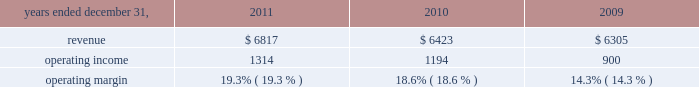2022 net derivative losses of $ 13 million .
Review by segment general we serve clients through the following segments : 2022 risk solutions acts as an advisor and insurance and reinsurance broker , helping clients manage their risks , via consultation , as well as negotiation and placement of insurance risk with insurance carriers through our global distribution network .
2022 hr solutions partners with organizations to solve their most complex benefits , talent and related financial challenges , and improve business performance by designing , implementing , communicating and administering a wide range of human capital , retirement , investment management , health care , compensation and talent management strategies .
Risk solutions .
The demand for property and casualty insurance generally rises as the overall level of economic activity increases and generally falls as such activity decreases , affecting both the commissions and fees generated by our brokerage business .
The economic activity that impacts property and casualty insurance is described as exposure units , and is closely correlated with employment levels , corporate revenue and asset values .
During 2011 we began to see some improvement in pricing ; however , we would still consider this to be a 2018 2018soft market , 2019 2019 which began in 2007 .
In a soft market , premium rates flatten or decrease , along with commission revenues , due to increased competition for market share among insurance carriers or increased underwriting capacity .
Changes in premiums have a direct and potentially material impact on the insurance brokerage industry , as commission revenues are generally based on a percentage of the premiums paid by insureds .
In 2011 , pricing showed signs of stabilization and improvement in both our retail and reinsurance brokerage product lines and we expect this trend to slowly continue into 2012 .
Additionally , beginning in late 2008 and continuing through 2011 , we faced difficult conditions as a result of unprecedented disruptions in the global economy , the repricing of credit risk and the deterioration of the financial markets .
Weak global economic conditions have reduced our customers 2019 demand for our brokerage products , which have had a negative impact on our operational results .
Risk solutions generated approximately 60% ( 60 % ) of our consolidated total revenues in 2011 .
Revenues are generated primarily through fees paid by clients , commissions and fees paid by insurance and reinsurance companies , and investment income on funds held on behalf of clients .
Our revenues vary from quarter to quarter throughout the year as a result of the timing of our clients 2019 policy renewals , the net effect of new and lost business , the timing of services provided to our clients , and the income we earn on investments , which is heavily influenced by short-term interest rates .
We operate in a highly competitive industry and compete with many retail insurance brokerage and agency firms , as well as with individual brokers , agents , and direct writers of insurance coverage .
Specifically , we address the highly specialized product development and risk management needs of commercial enterprises , professional groups , insurance companies , governments , health care providers , and non-profit groups , among others ; provide affinity products for professional liability , life , disability .
What is the increase observed in the operating margin during 2010 and 2011? 
Rationale: it is the difference between those margins .
Computations: (19.3% - 18.6%)
Answer: 0.007. 